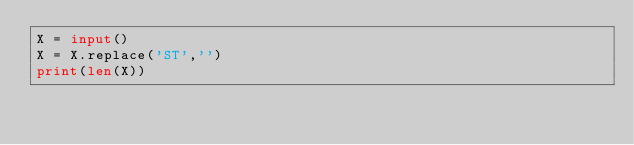Convert code to text. <code><loc_0><loc_0><loc_500><loc_500><_Python_>X = input()
X = X.replace('ST','')
print(len(X))
</code> 